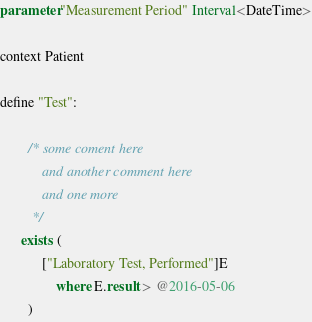Convert code to text. <code><loc_0><loc_0><loc_500><loc_500><_SQL_>
parameter "Measurement Period" Interval<DateTime>

context Patient

define "Test":

		/* some coment here
			and another comment here
			and one more
		 */
	  exists (
			["Laboratory Test, Performed"]E
				where E.result > @2016-05-06
		)</code> 